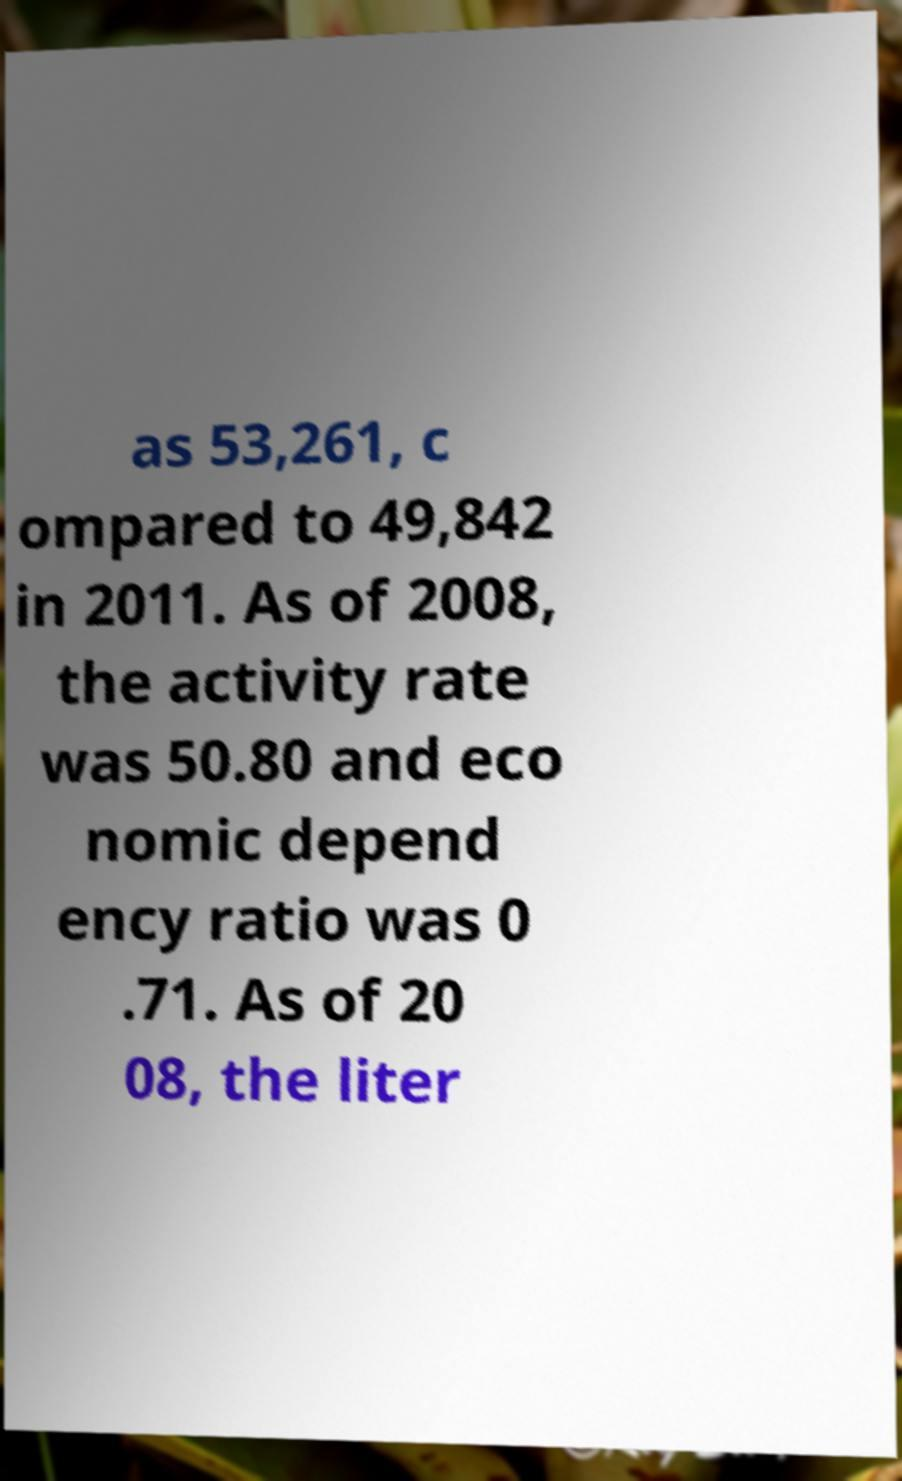Can you accurately transcribe the text from the provided image for me? as 53,261, c ompared to 49,842 in 2011. As of 2008, the activity rate was 50.80 and eco nomic depend ency ratio was 0 .71. As of 20 08, the liter 